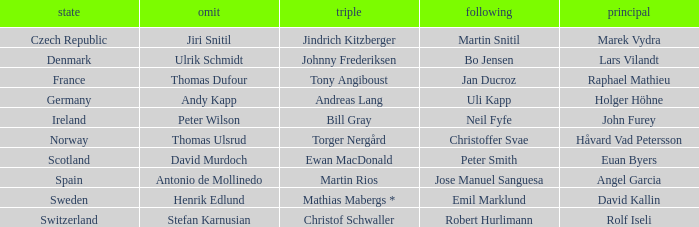Which Third has a Nation of scotland? Ewan MacDonald. Help me parse the entirety of this table. {'header': ['state', 'omit', 'triple', 'following', 'principal'], 'rows': [['Czech Republic', 'Jiri Snitil', 'Jindrich Kitzberger', 'Martin Snitil', 'Marek Vydra'], ['Denmark', 'Ulrik Schmidt', 'Johnny Frederiksen', 'Bo Jensen', 'Lars Vilandt'], ['France', 'Thomas Dufour', 'Tony Angiboust', 'Jan Ducroz', 'Raphael Mathieu'], ['Germany', 'Andy Kapp', 'Andreas Lang', 'Uli Kapp', 'Holger Höhne'], ['Ireland', 'Peter Wilson', 'Bill Gray', 'Neil Fyfe', 'John Furey'], ['Norway', 'Thomas Ulsrud', 'Torger Nergård', 'Christoffer Svae', 'Håvard Vad Petersson'], ['Scotland', 'David Murdoch', 'Ewan MacDonald', 'Peter Smith', 'Euan Byers'], ['Spain', 'Antonio de Mollinedo', 'Martin Rios', 'Jose Manuel Sanguesa', 'Angel Garcia'], ['Sweden', 'Henrik Edlund', 'Mathias Mabergs *', 'Emil Marklund', 'David Kallin'], ['Switzerland', 'Stefan Karnusian', 'Christof Schwaller', 'Robert Hurlimann', 'Rolf Iseli']]} 